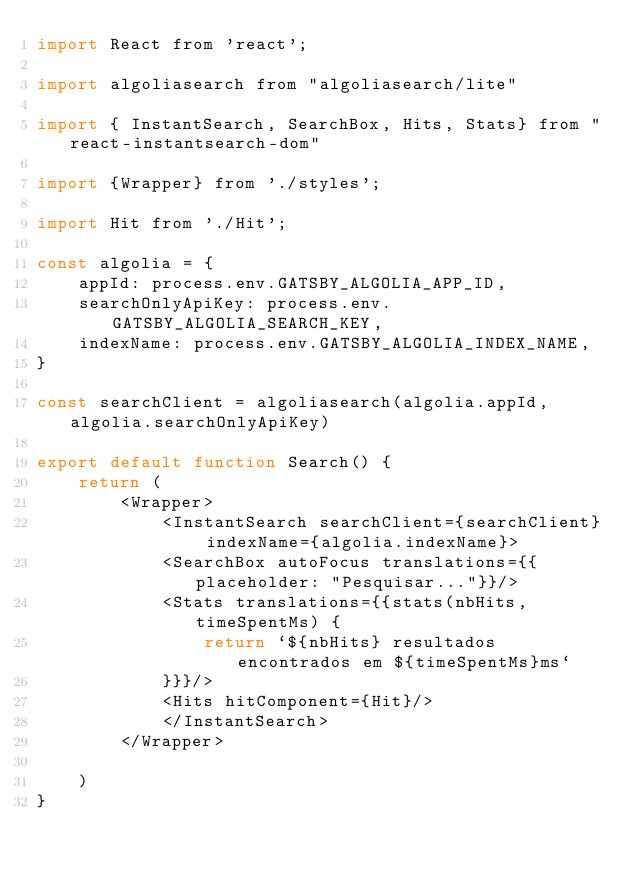<code> <loc_0><loc_0><loc_500><loc_500><_JavaScript_>import React from 'react';

import algoliasearch from "algoliasearch/lite"

import { InstantSearch, SearchBox, Hits, Stats} from "react-instantsearch-dom"

import {Wrapper} from './styles';

import Hit from './Hit';

const algolia = {
    appId: process.env.GATSBY_ALGOLIA_APP_ID,
    searchOnlyApiKey: process.env.GATSBY_ALGOLIA_SEARCH_KEY,
    indexName: process.env.GATSBY_ALGOLIA_INDEX_NAME,
}

const searchClient = algoliasearch(algolia.appId, algolia.searchOnlyApiKey)

export default function Search() {
    return (
        <Wrapper>
            <InstantSearch searchClient={searchClient} indexName={algolia.indexName}>
            <SearchBox autoFocus translations={{placeholder: "Pesquisar..."}}/>
            <Stats translations={{stats(nbHits, timeSpentMs) {
                return `${nbHits} resultados encontrados em ${timeSpentMs}ms`
            }}}/>
            <Hits hitComponent={Hit}/>
            </InstantSearch>
        </Wrapper>
        
    )
}</code> 